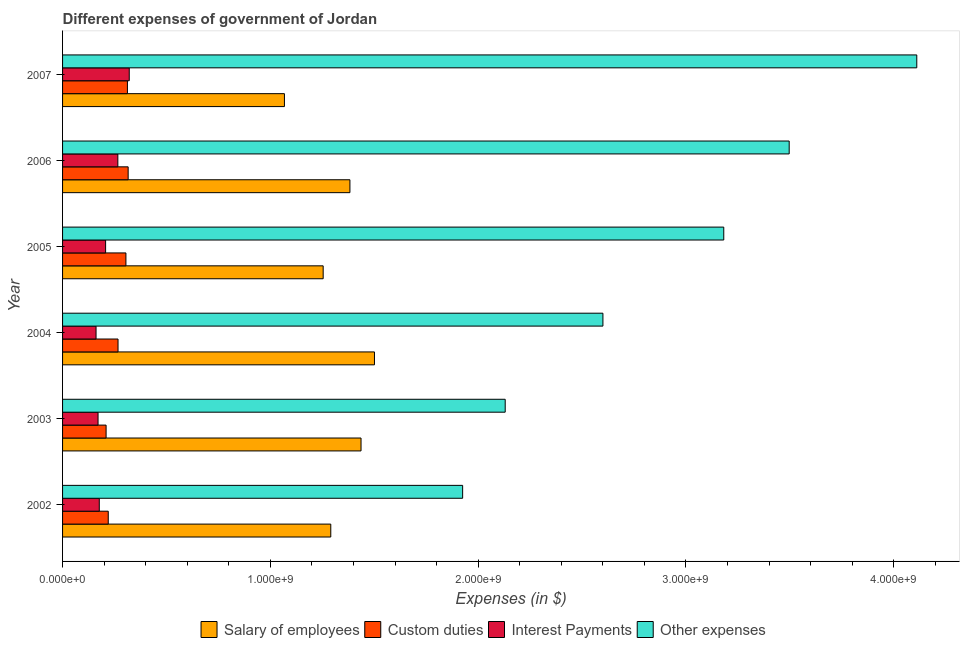How many different coloured bars are there?
Offer a very short reply. 4. Are the number of bars on each tick of the Y-axis equal?
Provide a short and direct response. Yes. How many bars are there on the 1st tick from the bottom?
Provide a succinct answer. 4. What is the label of the 6th group of bars from the top?
Ensure brevity in your answer.  2002. In how many cases, is the number of bars for a given year not equal to the number of legend labels?
Make the answer very short. 0. What is the amount spent on interest payments in 2003?
Your response must be concise. 1.71e+08. Across all years, what is the maximum amount spent on other expenses?
Your answer should be very brief. 4.11e+09. Across all years, what is the minimum amount spent on custom duties?
Provide a succinct answer. 2.09e+08. In which year was the amount spent on salary of employees maximum?
Offer a terse response. 2004. In which year was the amount spent on interest payments minimum?
Your answer should be compact. 2004. What is the total amount spent on other expenses in the graph?
Ensure brevity in your answer.  1.74e+1. What is the difference between the amount spent on interest payments in 2002 and that in 2007?
Offer a terse response. -1.44e+08. What is the difference between the amount spent on salary of employees in 2003 and the amount spent on custom duties in 2002?
Offer a terse response. 1.22e+09. What is the average amount spent on custom duties per year?
Provide a short and direct response. 2.71e+08. In the year 2005, what is the difference between the amount spent on salary of employees and amount spent on interest payments?
Give a very brief answer. 1.05e+09. Is the amount spent on interest payments in 2004 less than that in 2007?
Provide a short and direct response. Yes. What is the difference between the highest and the second highest amount spent on custom duties?
Make the answer very short. 3.54e+06. What is the difference between the highest and the lowest amount spent on salary of employees?
Keep it short and to the point. 4.33e+08. In how many years, is the amount spent on interest payments greater than the average amount spent on interest payments taken over all years?
Provide a short and direct response. 2. What does the 4th bar from the top in 2002 represents?
Your answer should be compact. Salary of employees. What does the 3rd bar from the bottom in 2007 represents?
Keep it short and to the point. Interest Payments. Is it the case that in every year, the sum of the amount spent on salary of employees and amount spent on custom duties is greater than the amount spent on interest payments?
Offer a very short reply. Yes. What is the difference between two consecutive major ticks on the X-axis?
Keep it short and to the point. 1.00e+09. Are the values on the major ticks of X-axis written in scientific E-notation?
Your response must be concise. Yes. Does the graph contain any zero values?
Offer a terse response. No. How are the legend labels stacked?
Your answer should be compact. Horizontal. What is the title of the graph?
Make the answer very short. Different expenses of government of Jordan. Does "Arable land" appear as one of the legend labels in the graph?
Offer a terse response. No. What is the label or title of the X-axis?
Provide a short and direct response. Expenses (in $). What is the label or title of the Y-axis?
Keep it short and to the point. Year. What is the Expenses (in $) of Salary of employees in 2002?
Keep it short and to the point. 1.29e+09. What is the Expenses (in $) of Custom duties in 2002?
Offer a very short reply. 2.20e+08. What is the Expenses (in $) of Interest Payments in 2002?
Your response must be concise. 1.77e+08. What is the Expenses (in $) of Other expenses in 2002?
Keep it short and to the point. 1.93e+09. What is the Expenses (in $) of Salary of employees in 2003?
Provide a short and direct response. 1.44e+09. What is the Expenses (in $) in Custom duties in 2003?
Provide a short and direct response. 2.09e+08. What is the Expenses (in $) in Interest Payments in 2003?
Ensure brevity in your answer.  1.71e+08. What is the Expenses (in $) of Other expenses in 2003?
Give a very brief answer. 2.13e+09. What is the Expenses (in $) of Salary of employees in 2004?
Offer a terse response. 1.50e+09. What is the Expenses (in $) in Custom duties in 2004?
Provide a succinct answer. 2.67e+08. What is the Expenses (in $) of Interest Payments in 2004?
Provide a short and direct response. 1.61e+08. What is the Expenses (in $) of Other expenses in 2004?
Give a very brief answer. 2.60e+09. What is the Expenses (in $) of Salary of employees in 2005?
Offer a very short reply. 1.25e+09. What is the Expenses (in $) in Custom duties in 2005?
Offer a very short reply. 3.05e+08. What is the Expenses (in $) in Interest Payments in 2005?
Your response must be concise. 2.07e+08. What is the Expenses (in $) of Other expenses in 2005?
Your answer should be very brief. 3.18e+09. What is the Expenses (in $) in Salary of employees in 2006?
Provide a succinct answer. 1.38e+09. What is the Expenses (in $) in Custom duties in 2006?
Give a very brief answer. 3.16e+08. What is the Expenses (in $) in Interest Payments in 2006?
Your answer should be compact. 2.66e+08. What is the Expenses (in $) in Other expenses in 2006?
Keep it short and to the point. 3.50e+09. What is the Expenses (in $) in Salary of employees in 2007?
Provide a short and direct response. 1.07e+09. What is the Expenses (in $) in Custom duties in 2007?
Your response must be concise. 3.12e+08. What is the Expenses (in $) in Interest Payments in 2007?
Keep it short and to the point. 3.21e+08. What is the Expenses (in $) in Other expenses in 2007?
Ensure brevity in your answer.  4.11e+09. Across all years, what is the maximum Expenses (in $) of Salary of employees?
Keep it short and to the point. 1.50e+09. Across all years, what is the maximum Expenses (in $) of Custom duties?
Offer a very short reply. 3.16e+08. Across all years, what is the maximum Expenses (in $) in Interest Payments?
Make the answer very short. 3.21e+08. Across all years, what is the maximum Expenses (in $) in Other expenses?
Your answer should be compact. 4.11e+09. Across all years, what is the minimum Expenses (in $) in Salary of employees?
Provide a succinct answer. 1.07e+09. Across all years, what is the minimum Expenses (in $) in Custom duties?
Provide a succinct answer. 2.09e+08. Across all years, what is the minimum Expenses (in $) in Interest Payments?
Keep it short and to the point. 1.61e+08. Across all years, what is the minimum Expenses (in $) in Other expenses?
Keep it short and to the point. 1.93e+09. What is the total Expenses (in $) of Salary of employees in the graph?
Offer a terse response. 7.93e+09. What is the total Expenses (in $) of Custom duties in the graph?
Keep it short and to the point. 1.63e+09. What is the total Expenses (in $) of Interest Payments in the graph?
Your response must be concise. 1.30e+09. What is the total Expenses (in $) of Other expenses in the graph?
Offer a terse response. 1.74e+1. What is the difference between the Expenses (in $) in Salary of employees in 2002 and that in 2003?
Provide a succinct answer. -1.46e+08. What is the difference between the Expenses (in $) of Custom duties in 2002 and that in 2003?
Keep it short and to the point. 1.04e+07. What is the difference between the Expenses (in $) in Interest Payments in 2002 and that in 2003?
Your answer should be very brief. 5.92e+06. What is the difference between the Expenses (in $) of Other expenses in 2002 and that in 2003?
Offer a very short reply. -2.05e+08. What is the difference between the Expenses (in $) in Salary of employees in 2002 and that in 2004?
Make the answer very short. -2.10e+08. What is the difference between the Expenses (in $) in Custom duties in 2002 and that in 2004?
Provide a succinct answer. -4.71e+07. What is the difference between the Expenses (in $) in Interest Payments in 2002 and that in 2004?
Offer a terse response. 1.56e+07. What is the difference between the Expenses (in $) in Other expenses in 2002 and that in 2004?
Your answer should be very brief. -6.75e+08. What is the difference between the Expenses (in $) in Salary of employees in 2002 and that in 2005?
Make the answer very short. 3.66e+07. What is the difference between the Expenses (in $) of Custom duties in 2002 and that in 2005?
Keep it short and to the point. -8.51e+07. What is the difference between the Expenses (in $) of Interest Payments in 2002 and that in 2005?
Provide a succinct answer. -3.04e+07. What is the difference between the Expenses (in $) in Other expenses in 2002 and that in 2005?
Give a very brief answer. -1.26e+09. What is the difference between the Expenses (in $) in Salary of employees in 2002 and that in 2006?
Offer a very short reply. -9.21e+07. What is the difference between the Expenses (in $) in Custom duties in 2002 and that in 2006?
Your response must be concise. -9.58e+07. What is the difference between the Expenses (in $) of Interest Payments in 2002 and that in 2006?
Ensure brevity in your answer.  -8.93e+07. What is the difference between the Expenses (in $) in Other expenses in 2002 and that in 2006?
Your response must be concise. -1.57e+09. What is the difference between the Expenses (in $) in Salary of employees in 2002 and that in 2007?
Provide a succinct answer. 2.23e+08. What is the difference between the Expenses (in $) of Custom duties in 2002 and that in 2007?
Offer a very short reply. -9.23e+07. What is the difference between the Expenses (in $) in Interest Payments in 2002 and that in 2007?
Keep it short and to the point. -1.44e+08. What is the difference between the Expenses (in $) of Other expenses in 2002 and that in 2007?
Provide a short and direct response. -2.19e+09. What is the difference between the Expenses (in $) of Salary of employees in 2003 and that in 2004?
Offer a terse response. -6.46e+07. What is the difference between the Expenses (in $) of Custom duties in 2003 and that in 2004?
Give a very brief answer. -5.75e+07. What is the difference between the Expenses (in $) in Interest Payments in 2003 and that in 2004?
Provide a succinct answer. 9.63e+06. What is the difference between the Expenses (in $) in Other expenses in 2003 and that in 2004?
Keep it short and to the point. -4.70e+08. What is the difference between the Expenses (in $) of Salary of employees in 2003 and that in 2005?
Offer a very short reply. 1.82e+08. What is the difference between the Expenses (in $) in Custom duties in 2003 and that in 2005?
Offer a terse response. -9.54e+07. What is the difference between the Expenses (in $) of Interest Payments in 2003 and that in 2005?
Make the answer very short. -3.64e+07. What is the difference between the Expenses (in $) of Other expenses in 2003 and that in 2005?
Provide a succinct answer. -1.05e+09. What is the difference between the Expenses (in $) in Salary of employees in 2003 and that in 2006?
Make the answer very short. 5.34e+07. What is the difference between the Expenses (in $) of Custom duties in 2003 and that in 2006?
Give a very brief answer. -1.06e+08. What is the difference between the Expenses (in $) in Interest Payments in 2003 and that in 2006?
Give a very brief answer. -9.52e+07. What is the difference between the Expenses (in $) of Other expenses in 2003 and that in 2006?
Keep it short and to the point. -1.37e+09. What is the difference between the Expenses (in $) in Salary of employees in 2003 and that in 2007?
Keep it short and to the point. 3.69e+08. What is the difference between the Expenses (in $) of Custom duties in 2003 and that in 2007?
Your response must be concise. -1.03e+08. What is the difference between the Expenses (in $) in Interest Payments in 2003 and that in 2007?
Make the answer very short. -1.50e+08. What is the difference between the Expenses (in $) in Other expenses in 2003 and that in 2007?
Your response must be concise. -1.98e+09. What is the difference between the Expenses (in $) in Salary of employees in 2004 and that in 2005?
Your response must be concise. 2.47e+08. What is the difference between the Expenses (in $) in Custom duties in 2004 and that in 2005?
Give a very brief answer. -3.80e+07. What is the difference between the Expenses (in $) in Interest Payments in 2004 and that in 2005?
Provide a short and direct response. -4.60e+07. What is the difference between the Expenses (in $) of Other expenses in 2004 and that in 2005?
Give a very brief answer. -5.82e+08. What is the difference between the Expenses (in $) of Salary of employees in 2004 and that in 2006?
Your response must be concise. 1.18e+08. What is the difference between the Expenses (in $) of Custom duties in 2004 and that in 2006?
Provide a succinct answer. -4.87e+07. What is the difference between the Expenses (in $) of Interest Payments in 2004 and that in 2006?
Offer a very short reply. -1.05e+08. What is the difference between the Expenses (in $) of Other expenses in 2004 and that in 2006?
Ensure brevity in your answer.  -8.96e+08. What is the difference between the Expenses (in $) in Salary of employees in 2004 and that in 2007?
Provide a succinct answer. 4.33e+08. What is the difference between the Expenses (in $) in Custom duties in 2004 and that in 2007?
Provide a short and direct response. -4.52e+07. What is the difference between the Expenses (in $) in Interest Payments in 2004 and that in 2007?
Your answer should be compact. -1.60e+08. What is the difference between the Expenses (in $) of Other expenses in 2004 and that in 2007?
Give a very brief answer. -1.51e+09. What is the difference between the Expenses (in $) of Salary of employees in 2005 and that in 2006?
Keep it short and to the point. -1.29e+08. What is the difference between the Expenses (in $) of Custom duties in 2005 and that in 2006?
Provide a short and direct response. -1.07e+07. What is the difference between the Expenses (in $) of Interest Payments in 2005 and that in 2006?
Keep it short and to the point. -5.89e+07. What is the difference between the Expenses (in $) of Other expenses in 2005 and that in 2006?
Ensure brevity in your answer.  -3.15e+08. What is the difference between the Expenses (in $) in Salary of employees in 2005 and that in 2007?
Offer a terse response. 1.86e+08. What is the difference between the Expenses (in $) of Custom duties in 2005 and that in 2007?
Make the answer very short. -7.20e+06. What is the difference between the Expenses (in $) of Interest Payments in 2005 and that in 2007?
Provide a succinct answer. -1.14e+08. What is the difference between the Expenses (in $) of Other expenses in 2005 and that in 2007?
Offer a very short reply. -9.29e+08. What is the difference between the Expenses (in $) of Salary of employees in 2006 and that in 2007?
Your answer should be very brief. 3.15e+08. What is the difference between the Expenses (in $) of Custom duties in 2006 and that in 2007?
Provide a short and direct response. 3.54e+06. What is the difference between the Expenses (in $) of Interest Payments in 2006 and that in 2007?
Offer a very short reply. -5.49e+07. What is the difference between the Expenses (in $) in Other expenses in 2006 and that in 2007?
Offer a terse response. -6.14e+08. What is the difference between the Expenses (in $) in Salary of employees in 2002 and the Expenses (in $) in Custom duties in 2003?
Offer a very short reply. 1.08e+09. What is the difference between the Expenses (in $) in Salary of employees in 2002 and the Expenses (in $) in Interest Payments in 2003?
Ensure brevity in your answer.  1.12e+09. What is the difference between the Expenses (in $) in Salary of employees in 2002 and the Expenses (in $) in Other expenses in 2003?
Provide a succinct answer. -8.39e+08. What is the difference between the Expenses (in $) in Custom duties in 2002 and the Expenses (in $) in Interest Payments in 2003?
Your answer should be compact. 4.91e+07. What is the difference between the Expenses (in $) in Custom duties in 2002 and the Expenses (in $) in Other expenses in 2003?
Your answer should be very brief. -1.91e+09. What is the difference between the Expenses (in $) in Interest Payments in 2002 and the Expenses (in $) in Other expenses in 2003?
Make the answer very short. -1.95e+09. What is the difference between the Expenses (in $) in Salary of employees in 2002 and the Expenses (in $) in Custom duties in 2004?
Your answer should be compact. 1.02e+09. What is the difference between the Expenses (in $) of Salary of employees in 2002 and the Expenses (in $) of Interest Payments in 2004?
Your response must be concise. 1.13e+09. What is the difference between the Expenses (in $) in Salary of employees in 2002 and the Expenses (in $) in Other expenses in 2004?
Your answer should be very brief. -1.31e+09. What is the difference between the Expenses (in $) of Custom duties in 2002 and the Expenses (in $) of Interest Payments in 2004?
Offer a terse response. 5.87e+07. What is the difference between the Expenses (in $) in Custom duties in 2002 and the Expenses (in $) in Other expenses in 2004?
Your answer should be compact. -2.38e+09. What is the difference between the Expenses (in $) of Interest Payments in 2002 and the Expenses (in $) of Other expenses in 2004?
Make the answer very short. -2.42e+09. What is the difference between the Expenses (in $) of Salary of employees in 2002 and the Expenses (in $) of Custom duties in 2005?
Keep it short and to the point. 9.86e+08. What is the difference between the Expenses (in $) of Salary of employees in 2002 and the Expenses (in $) of Interest Payments in 2005?
Offer a terse response. 1.08e+09. What is the difference between the Expenses (in $) in Salary of employees in 2002 and the Expenses (in $) in Other expenses in 2005?
Provide a succinct answer. -1.89e+09. What is the difference between the Expenses (in $) in Custom duties in 2002 and the Expenses (in $) in Interest Payments in 2005?
Offer a very short reply. 1.27e+07. What is the difference between the Expenses (in $) in Custom duties in 2002 and the Expenses (in $) in Other expenses in 2005?
Your response must be concise. -2.96e+09. What is the difference between the Expenses (in $) in Interest Payments in 2002 and the Expenses (in $) in Other expenses in 2005?
Your answer should be compact. -3.01e+09. What is the difference between the Expenses (in $) in Salary of employees in 2002 and the Expenses (in $) in Custom duties in 2006?
Your answer should be very brief. 9.75e+08. What is the difference between the Expenses (in $) in Salary of employees in 2002 and the Expenses (in $) in Interest Payments in 2006?
Provide a short and direct response. 1.02e+09. What is the difference between the Expenses (in $) in Salary of employees in 2002 and the Expenses (in $) in Other expenses in 2006?
Provide a succinct answer. -2.21e+09. What is the difference between the Expenses (in $) of Custom duties in 2002 and the Expenses (in $) of Interest Payments in 2006?
Ensure brevity in your answer.  -4.62e+07. What is the difference between the Expenses (in $) in Custom duties in 2002 and the Expenses (in $) in Other expenses in 2006?
Offer a very short reply. -3.28e+09. What is the difference between the Expenses (in $) of Interest Payments in 2002 and the Expenses (in $) of Other expenses in 2006?
Offer a very short reply. -3.32e+09. What is the difference between the Expenses (in $) of Salary of employees in 2002 and the Expenses (in $) of Custom duties in 2007?
Your answer should be compact. 9.79e+08. What is the difference between the Expenses (in $) in Salary of employees in 2002 and the Expenses (in $) in Interest Payments in 2007?
Keep it short and to the point. 9.70e+08. What is the difference between the Expenses (in $) in Salary of employees in 2002 and the Expenses (in $) in Other expenses in 2007?
Give a very brief answer. -2.82e+09. What is the difference between the Expenses (in $) in Custom duties in 2002 and the Expenses (in $) in Interest Payments in 2007?
Give a very brief answer. -1.01e+08. What is the difference between the Expenses (in $) in Custom duties in 2002 and the Expenses (in $) in Other expenses in 2007?
Ensure brevity in your answer.  -3.89e+09. What is the difference between the Expenses (in $) in Interest Payments in 2002 and the Expenses (in $) in Other expenses in 2007?
Your answer should be compact. -3.93e+09. What is the difference between the Expenses (in $) in Salary of employees in 2003 and the Expenses (in $) in Custom duties in 2004?
Provide a short and direct response. 1.17e+09. What is the difference between the Expenses (in $) of Salary of employees in 2003 and the Expenses (in $) of Interest Payments in 2004?
Provide a short and direct response. 1.28e+09. What is the difference between the Expenses (in $) in Salary of employees in 2003 and the Expenses (in $) in Other expenses in 2004?
Ensure brevity in your answer.  -1.16e+09. What is the difference between the Expenses (in $) of Custom duties in 2003 and the Expenses (in $) of Interest Payments in 2004?
Ensure brevity in your answer.  4.84e+07. What is the difference between the Expenses (in $) of Custom duties in 2003 and the Expenses (in $) of Other expenses in 2004?
Your answer should be compact. -2.39e+09. What is the difference between the Expenses (in $) of Interest Payments in 2003 and the Expenses (in $) of Other expenses in 2004?
Make the answer very short. -2.43e+09. What is the difference between the Expenses (in $) in Salary of employees in 2003 and the Expenses (in $) in Custom duties in 2005?
Give a very brief answer. 1.13e+09. What is the difference between the Expenses (in $) of Salary of employees in 2003 and the Expenses (in $) of Interest Payments in 2005?
Give a very brief answer. 1.23e+09. What is the difference between the Expenses (in $) in Salary of employees in 2003 and the Expenses (in $) in Other expenses in 2005?
Ensure brevity in your answer.  -1.75e+09. What is the difference between the Expenses (in $) in Custom duties in 2003 and the Expenses (in $) in Interest Payments in 2005?
Offer a very short reply. 2.35e+06. What is the difference between the Expenses (in $) of Custom duties in 2003 and the Expenses (in $) of Other expenses in 2005?
Your answer should be compact. -2.97e+09. What is the difference between the Expenses (in $) in Interest Payments in 2003 and the Expenses (in $) in Other expenses in 2005?
Your answer should be very brief. -3.01e+09. What is the difference between the Expenses (in $) of Salary of employees in 2003 and the Expenses (in $) of Custom duties in 2006?
Keep it short and to the point. 1.12e+09. What is the difference between the Expenses (in $) of Salary of employees in 2003 and the Expenses (in $) of Interest Payments in 2006?
Ensure brevity in your answer.  1.17e+09. What is the difference between the Expenses (in $) in Salary of employees in 2003 and the Expenses (in $) in Other expenses in 2006?
Keep it short and to the point. -2.06e+09. What is the difference between the Expenses (in $) in Custom duties in 2003 and the Expenses (in $) in Interest Payments in 2006?
Make the answer very short. -5.65e+07. What is the difference between the Expenses (in $) in Custom duties in 2003 and the Expenses (in $) in Other expenses in 2006?
Offer a terse response. -3.29e+09. What is the difference between the Expenses (in $) of Interest Payments in 2003 and the Expenses (in $) of Other expenses in 2006?
Provide a succinct answer. -3.33e+09. What is the difference between the Expenses (in $) in Salary of employees in 2003 and the Expenses (in $) in Custom duties in 2007?
Your answer should be very brief. 1.12e+09. What is the difference between the Expenses (in $) in Salary of employees in 2003 and the Expenses (in $) in Interest Payments in 2007?
Make the answer very short. 1.12e+09. What is the difference between the Expenses (in $) in Salary of employees in 2003 and the Expenses (in $) in Other expenses in 2007?
Provide a succinct answer. -2.67e+09. What is the difference between the Expenses (in $) in Custom duties in 2003 and the Expenses (in $) in Interest Payments in 2007?
Offer a very short reply. -1.11e+08. What is the difference between the Expenses (in $) of Custom duties in 2003 and the Expenses (in $) of Other expenses in 2007?
Keep it short and to the point. -3.90e+09. What is the difference between the Expenses (in $) in Interest Payments in 2003 and the Expenses (in $) in Other expenses in 2007?
Keep it short and to the point. -3.94e+09. What is the difference between the Expenses (in $) of Salary of employees in 2004 and the Expenses (in $) of Custom duties in 2005?
Ensure brevity in your answer.  1.20e+09. What is the difference between the Expenses (in $) in Salary of employees in 2004 and the Expenses (in $) in Interest Payments in 2005?
Give a very brief answer. 1.29e+09. What is the difference between the Expenses (in $) in Salary of employees in 2004 and the Expenses (in $) in Other expenses in 2005?
Keep it short and to the point. -1.68e+09. What is the difference between the Expenses (in $) in Custom duties in 2004 and the Expenses (in $) in Interest Payments in 2005?
Ensure brevity in your answer.  5.98e+07. What is the difference between the Expenses (in $) of Custom duties in 2004 and the Expenses (in $) of Other expenses in 2005?
Your answer should be very brief. -2.91e+09. What is the difference between the Expenses (in $) of Interest Payments in 2004 and the Expenses (in $) of Other expenses in 2005?
Your answer should be very brief. -3.02e+09. What is the difference between the Expenses (in $) of Salary of employees in 2004 and the Expenses (in $) of Custom duties in 2006?
Your answer should be very brief. 1.19e+09. What is the difference between the Expenses (in $) of Salary of employees in 2004 and the Expenses (in $) of Interest Payments in 2006?
Give a very brief answer. 1.23e+09. What is the difference between the Expenses (in $) in Salary of employees in 2004 and the Expenses (in $) in Other expenses in 2006?
Make the answer very short. -2.00e+09. What is the difference between the Expenses (in $) of Custom duties in 2004 and the Expenses (in $) of Interest Payments in 2006?
Offer a very short reply. 9.26e+05. What is the difference between the Expenses (in $) of Custom duties in 2004 and the Expenses (in $) of Other expenses in 2006?
Your answer should be compact. -3.23e+09. What is the difference between the Expenses (in $) in Interest Payments in 2004 and the Expenses (in $) in Other expenses in 2006?
Your answer should be compact. -3.34e+09. What is the difference between the Expenses (in $) of Salary of employees in 2004 and the Expenses (in $) of Custom duties in 2007?
Your answer should be very brief. 1.19e+09. What is the difference between the Expenses (in $) of Salary of employees in 2004 and the Expenses (in $) of Interest Payments in 2007?
Your answer should be very brief. 1.18e+09. What is the difference between the Expenses (in $) of Salary of employees in 2004 and the Expenses (in $) of Other expenses in 2007?
Keep it short and to the point. -2.61e+09. What is the difference between the Expenses (in $) in Custom duties in 2004 and the Expenses (in $) in Interest Payments in 2007?
Your answer should be very brief. -5.40e+07. What is the difference between the Expenses (in $) in Custom duties in 2004 and the Expenses (in $) in Other expenses in 2007?
Make the answer very short. -3.84e+09. What is the difference between the Expenses (in $) of Interest Payments in 2004 and the Expenses (in $) of Other expenses in 2007?
Your answer should be very brief. -3.95e+09. What is the difference between the Expenses (in $) in Salary of employees in 2005 and the Expenses (in $) in Custom duties in 2006?
Offer a terse response. 9.38e+08. What is the difference between the Expenses (in $) of Salary of employees in 2005 and the Expenses (in $) of Interest Payments in 2006?
Give a very brief answer. 9.88e+08. What is the difference between the Expenses (in $) of Salary of employees in 2005 and the Expenses (in $) of Other expenses in 2006?
Keep it short and to the point. -2.24e+09. What is the difference between the Expenses (in $) in Custom duties in 2005 and the Expenses (in $) in Interest Payments in 2006?
Your answer should be compact. 3.89e+07. What is the difference between the Expenses (in $) in Custom duties in 2005 and the Expenses (in $) in Other expenses in 2006?
Make the answer very short. -3.19e+09. What is the difference between the Expenses (in $) of Interest Payments in 2005 and the Expenses (in $) of Other expenses in 2006?
Your response must be concise. -3.29e+09. What is the difference between the Expenses (in $) of Salary of employees in 2005 and the Expenses (in $) of Custom duties in 2007?
Your response must be concise. 9.42e+08. What is the difference between the Expenses (in $) of Salary of employees in 2005 and the Expenses (in $) of Interest Payments in 2007?
Your answer should be very brief. 9.33e+08. What is the difference between the Expenses (in $) in Salary of employees in 2005 and the Expenses (in $) in Other expenses in 2007?
Offer a terse response. -2.86e+09. What is the difference between the Expenses (in $) in Custom duties in 2005 and the Expenses (in $) in Interest Payments in 2007?
Offer a very short reply. -1.60e+07. What is the difference between the Expenses (in $) in Custom duties in 2005 and the Expenses (in $) in Other expenses in 2007?
Provide a succinct answer. -3.81e+09. What is the difference between the Expenses (in $) in Interest Payments in 2005 and the Expenses (in $) in Other expenses in 2007?
Your response must be concise. -3.90e+09. What is the difference between the Expenses (in $) of Salary of employees in 2006 and the Expenses (in $) of Custom duties in 2007?
Give a very brief answer. 1.07e+09. What is the difference between the Expenses (in $) of Salary of employees in 2006 and the Expenses (in $) of Interest Payments in 2007?
Your answer should be compact. 1.06e+09. What is the difference between the Expenses (in $) in Salary of employees in 2006 and the Expenses (in $) in Other expenses in 2007?
Make the answer very short. -2.73e+09. What is the difference between the Expenses (in $) of Custom duties in 2006 and the Expenses (in $) of Interest Payments in 2007?
Your response must be concise. -5.26e+06. What is the difference between the Expenses (in $) of Custom duties in 2006 and the Expenses (in $) of Other expenses in 2007?
Give a very brief answer. -3.79e+09. What is the difference between the Expenses (in $) of Interest Payments in 2006 and the Expenses (in $) of Other expenses in 2007?
Give a very brief answer. -3.84e+09. What is the average Expenses (in $) in Salary of employees per year?
Offer a very short reply. 1.32e+09. What is the average Expenses (in $) in Custom duties per year?
Provide a short and direct response. 2.71e+08. What is the average Expenses (in $) of Interest Payments per year?
Provide a succinct answer. 2.17e+08. What is the average Expenses (in $) in Other expenses per year?
Offer a terse response. 2.91e+09. In the year 2002, what is the difference between the Expenses (in $) in Salary of employees and Expenses (in $) in Custom duties?
Keep it short and to the point. 1.07e+09. In the year 2002, what is the difference between the Expenses (in $) of Salary of employees and Expenses (in $) of Interest Payments?
Provide a succinct answer. 1.11e+09. In the year 2002, what is the difference between the Expenses (in $) in Salary of employees and Expenses (in $) in Other expenses?
Provide a short and direct response. -6.34e+08. In the year 2002, what is the difference between the Expenses (in $) of Custom duties and Expenses (in $) of Interest Payments?
Make the answer very short. 4.32e+07. In the year 2002, what is the difference between the Expenses (in $) of Custom duties and Expenses (in $) of Other expenses?
Give a very brief answer. -1.71e+09. In the year 2002, what is the difference between the Expenses (in $) of Interest Payments and Expenses (in $) of Other expenses?
Provide a succinct answer. -1.75e+09. In the year 2003, what is the difference between the Expenses (in $) in Salary of employees and Expenses (in $) in Custom duties?
Your answer should be compact. 1.23e+09. In the year 2003, what is the difference between the Expenses (in $) of Salary of employees and Expenses (in $) of Interest Payments?
Provide a succinct answer. 1.27e+09. In the year 2003, what is the difference between the Expenses (in $) of Salary of employees and Expenses (in $) of Other expenses?
Provide a short and direct response. -6.94e+08. In the year 2003, what is the difference between the Expenses (in $) of Custom duties and Expenses (in $) of Interest Payments?
Offer a terse response. 3.87e+07. In the year 2003, what is the difference between the Expenses (in $) in Custom duties and Expenses (in $) in Other expenses?
Make the answer very short. -1.92e+09. In the year 2003, what is the difference between the Expenses (in $) of Interest Payments and Expenses (in $) of Other expenses?
Offer a very short reply. -1.96e+09. In the year 2004, what is the difference between the Expenses (in $) of Salary of employees and Expenses (in $) of Custom duties?
Offer a very short reply. 1.23e+09. In the year 2004, what is the difference between the Expenses (in $) of Salary of employees and Expenses (in $) of Interest Payments?
Ensure brevity in your answer.  1.34e+09. In the year 2004, what is the difference between the Expenses (in $) of Salary of employees and Expenses (in $) of Other expenses?
Keep it short and to the point. -1.10e+09. In the year 2004, what is the difference between the Expenses (in $) in Custom duties and Expenses (in $) in Interest Payments?
Make the answer very short. 1.06e+08. In the year 2004, what is the difference between the Expenses (in $) of Custom duties and Expenses (in $) of Other expenses?
Your answer should be very brief. -2.33e+09. In the year 2004, what is the difference between the Expenses (in $) of Interest Payments and Expenses (in $) of Other expenses?
Ensure brevity in your answer.  -2.44e+09. In the year 2005, what is the difference between the Expenses (in $) of Salary of employees and Expenses (in $) of Custom duties?
Make the answer very short. 9.49e+08. In the year 2005, what is the difference between the Expenses (in $) of Salary of employees and Expenses (in $) of Interest Payments?
Offer a terse response. 1.05e+09. In the year 2005, what is the difference between the Expenses (in $) in Salary of employees and Expenses (in $) in Other expenses?
Offer a terse response. -1.93e+09. In the year 2005, what is the difference between the Expenses (in $) of Custom duties and Expenses (in $) of Interest Payments?
Offer a terse response. 9.78e+07. In the year 2005, what is the difference between the Expenses (in $) in Custom duties and Expenses (in $) in Other expenses?
Offer a very short reply. -2.88e+09. In the year 2005, what is the difference between the Expenses (in $) in Interest Payments and Expenses (in $) in Other expenses?
Ensure brevity in your answer.  -2.97e+09. In the year 2006, what is the difference between the Expenses (in $) of Salary of employees and Expenses (in $) of Custom duties?
Provide a succinct answer. 1.07e+09. In the year 2006, what is the difference between the Expenses (in $) of Salary of employees and Expenses (in $) of Interest Payments?
Keep it short and to the point. 1.12e+09. In the year 2006, what is the difference between the Expenses (in $) in Salary of employees and Expenses (in $) in Other expenses?
Your answer should be very brief. -2.11e+09. In the year 2006, what is the difference between the Expenses (in $) in Custom duties and Expenses (in $) in Interest Payments?
Provide a short and direct response. 4.97e+07. In the year 2006, what is the difference between the Expenses (in $) of Custom duties and Expenses (in $) of Other expenses?
Make the answer very short. -3.18e+09. In the year 2006, what is the difference between the Expenses (in $) in Interest Payments and Expenses (in $) in Other expenses?
Provide a short and direct response. -3.23e+09. In the year 2007, what is the difference between the Expenses (in $) of Salary of employees and Expenses (in $) of Custom duties?
Give a very brief answer. 7.56e+08. In the year 2007, what is the difference between the Expenses (in $) of Salary of employees and Expenses (in $) of Interest Payments?
Provide a short and direct response. 7.47e+08. In the year 2007, what is the difference between the Expenses (in $) of Salary of employees and Expenses (in $) of Other expenses?
Offer a terse response. -3.04e+09. In the year 2007, what is the difference between the Expenses (in $) of Custom duties and Expenses (in $) of Interest Payments?
Ensure brevity in your answer.  -8.80e+06. In the year 2007, what is the difference between the Expenses (in $) in Custom duties and Expenses (in $) in Other expenses?
Offer a terse response. -3.80e+09. In the year 2007, what is the difference between the Expenses (in $) in Interest Payments and Expenses (in $) in Other expenses?
Make the answer very short. -3.79e+09. What is the ratio of the Expenses (in $) in Salary of employees in 2002 to that in 2003?
Offer a terse response. 0.9. What is the ratio of the Expenses (in $) of Custom duties in 2002 to that in 2003?
Your response must be concise. 1.05. What is the ratio of the Expenses (in $) in Interest Payments in 2002 to that in 2003?
Your response must be concise. 1.03. What is the ratio of the Expenses (in $) of Other expenses in 2002 to that in 2003?
Provide a short and direct response. 0.9. What is the ratio of the Expenses (in $) of Salary of employees in 2002 to that in 2004?
Give a very brief answer. 0.86. What is the ratio of the Expenses (in $) of Custom duties in 2002 to that in 2004?
Ensure brevity in your answer.  0.82. What is the ratio of the Expenses (in $) in Interest Payments in 2002 to that in 2004?
Your answer should be compact. 1.1. What is the ratio of the Expenses (in $) in Other expenses in 2002 to that in 2004?
Your answer should be compact. 0.74. What is the ratio of the Expenses (in $) in Salary of employees in 2002 to that in 2005?
Keep it short and to the point. 1.03. What is the ratio of the Expenses (in $) of Custom duties in 2002 to that in 2005?
Make the answer very short. 0.72. What is the ratio of the Expenses (in $) in Interest Payments in 2002 to that in 2005?
Keep it short and to the point. 0.85. What is the ratio of the Expenses (in $) of Other expenses in 2002 to that in 2005?
Your answer should be compact. 0.61. What is the ratio of the Expenses (in $) in Salary of employees in 2002 to that in 2006?
Provide a succinct answer. 0.93. What is the ratio of the Expenses (in $) in Custom duties in 2002 to that in 2006?
Ensure brevity in your answer.  0.7. What is the ratio of the Expenses (in $) of Interest Payments in 2002 to that in 2006?
Offer a very short reply. 0.66. What is the ratio of the Expenses (in $) of Other expenses in 2002 to that in 2006?
Make the answer very short. 0.55. What is the ratio of the Expenses (in $) in Salary of employees in 2002 to that in 2007?
Offer a terse response. 1.21. What is the ratio of the Expenses (in $) of Custom duties in 2002 to that in 2007?
Keep it short and to the point. 0.7. What is the ratio of the Expenses (in $) of Interest Payments in 2002 to that in 2007?
Provide a short and direct response. 0.55. What is the ratio of the Expenses (in $) of Other expenses in 2002 to that in 2007?
Your answer should be compact. 0.47. What is the ratio of the Expenses (in $) in Salary of employees in 2003 to that in 2004?
Offer a terse response. 0.96. What is the ratio of the Expenses (in $) of Custom duties in 2003 to that in 2004?
Your response must be concise. 0.78. What is the ratio of the Expenses (in $) of Interest Payments in 2003 to that in 2004?
Offer a very short reply. 1.06. What is the ratio of the Expenses (in $) of Other expenses in 2003 to that in 2004?
Provide a succinct answer. 0.82. What is the ratio of the Expenses (in $) in Salary of employees in 2003 to that in 2005?
Ensure brevity in your answer.  1.15. What is the ratio of the Expenses (in $) in Custom duties in 2003 to that in 2005?
Provide a succinct answer. 0.69. What is the ratio of the Expenses (in $) of Interest Payments in 2003 to that in 2005?
Offer a very short reply. 0.82. What is the ratio of the Expenses (in $) in Other expenses in 2003 to that in 2005?
Ensure brevity in your answer.  0.67. What is the ratio of the Expenses (in $) in Salary of employees in 2003 to that in 2006?
Keep it short and to the point. 1.04. What is the ratio of the Expenses (in $) in Custom duties in 2003 to that in 2006?
Provide a short and direct response. 0.66. What is the ratio of the Expenses (in $) in Interest Payments in 2003 to that in 2006?
Make the answer very short. 0.64. What is the ratio of the Expenses (in $) of Other expenses in 2003 to that in 2006?
Provide a succinct answer. 0.61. What is the ratio of the Expenses (in $) in Salary of employees in 2003 to that in 2007?
Provide a short and direct response. 1.35. What is the ratio of the Expenses (in $) of Custom duties in 2003 to that in 2007?
Provide a succinct answer. 0.67. What is the ratio of the Expenses (in $) of Interest Payments in 2003 to that in 2007?
Your answer should be compact. 0.53. What is the ratio of the Expenses (in $) in Other expenses in 2003 to that in 2007?
Keep it short and to the point. 0.52. What is the ratio of the Expenses (in $) in Salary of employees in 2004 to that in 2005?
Offer a very short reply. 1.2. What is the ratio of the Expenses (in $) in Custom duties in 2004 to that in 2005?
Provide a succinct answer. 0.88. What is the ratio of the Expenses (in $) in Interest Payments in 2004 to that in 2005?
Make the answer very short. 0.78. What is the ratio of the Expenses (in $) in Other expenses in 2004 to that in 2005?
Your answer should be compact. 0.82. What is the ratio of the Expenses (in $) in Salary of employees in 2004 to that in 2006?
Keep it short and to the point. 1.09. What is the ratio of the Expenses (in $) in Custom duties in 2004 to that in 2006?
Offer a terse response. 0.85. What is the ratio of the Expenses (in $) of Interest Payments in 2004 to that in 2006?
Your response must be concise. 0.61. What is the ratio of the Expenses (in $) of Other expenses in 2004 to that in 2006?
Provide a succinct answer. 0.74. What is the ratio of the Expenses (in $) of Salary of employees in 2004 to that in 2007?
Ensure brevity in your answer.  1.41. What is the ratio of the Expenses (in $) of Custom duties in 2004 to that in 2007?
Make the answer very short. 0.86. What is the ratio of the Expenses (in $) in Interest Payments in 2004 to that in 2007?
Give a very brief answer. 0.5. What is the ratio of the Expenses (in $) in Other expenses in 2004 to that in 2007?
Your response must be concise. 0.63. What is the ratio of the Expenses (in $) of Salary of employees in 2005 to that in 2006?
Offer a terse response. 0.91. What is the ratio of the Expenses (in $) in Custom duties in 2005 to that in 2006?
Your answer should be very brief. 0.97. What is the ratio of the Expenses (in $) in Interest Payments in 2005 to that in 2006?
Give a very brief answer. 0.78. What is the ratio of the Expenses (in $) of Other expenses in 2005 to that in 2006?
Your answer should be compact. 0.91. What is the ratio of the Expenses (in $) of Salary of employees in 2005 to that in 2007?
Offer a terse response. 1.17. What is the ratio of the Expenses (in $) of Custom duties in 2005 to that in 2007?
Make the answer very short. 0.98. What is the ratio of the Expenses (in $) in Interest Payments in 2005 to that in 2007?
Your answer should be very brief. 0.65. What is the ratio of the Expenses (in $) in Other expenses in 2005 to that in 2007?
Provide a short and direct response. 0.77. What is the ratio of the Expenses (in $) in Salary of employees in 2006 to that in 2007?
Offer a terse response. 1.3. What is the ratio of the Expenses (in $) of Custom duties in 2006 to that in 2007?
Keep it short and to the point. 1.01. What is the ratio of the Expenses (in $) of Interest Payments in 2006 to that in 2007?
Give a very brief answer. 0.83. What is the ratio of the Expenses (in $) of Other expenses in 2006 to that in 2007?
Your answer should be very brief. 0.85. What is the difference between the highest and the second highest Expenses (in $) in Salary of employees?
Make the answer very short. 6.46e+07. What is the difference between the highest and the second highest Expenses (in $) of Custom duties?
Provide a short and direct response. 3.54e+06. What is the difference between the highest and the second highest Expenses (in $) of Interest Payments?
Provide a succinct answer. 5.49e+07. What is the difference between the highest and the second highest Expenses (in $) of Other expenses?
Your answer should be very brief. 6.14e+08. What is the difference between the highest and the lowest Expenses (in $) of Salary of employees?
Provide a succinct answer. 4.33e+08. What is the difference between the highest and the lowest Expenses (in $) of Custom duties?
Your response must be concise. 1.06e+08. What is the difference between the highest and the lowest Expenses (in $) of Interest Payments?
Your response must be concise. 1.60e+08. What is the difference between the highest and the lowest Expenses (in $) in Other expenses?
Your response must be concise. 2.19e+09. 